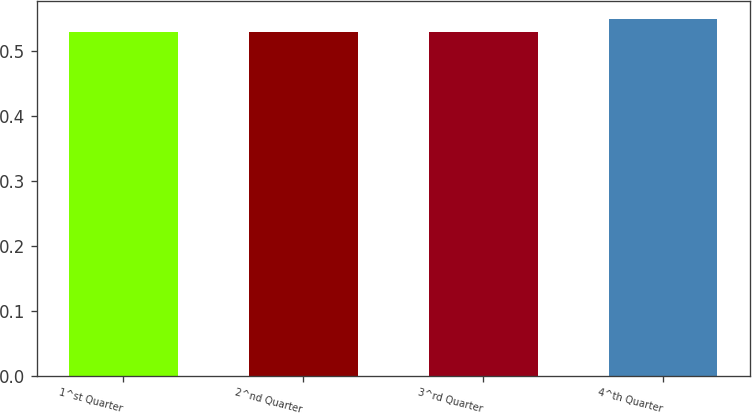<chart> <loc_0><loc_0><loc_500><loc_500><bar_chart><fcel>1^st Quarter<fcel>2^nd Quarter<fcel>3^rd Quarter<fcel>4^th Quarter<nl><fcel>0.53<fcel>0.53<fcel>0.53<fcel>0.55<nl></chart> 